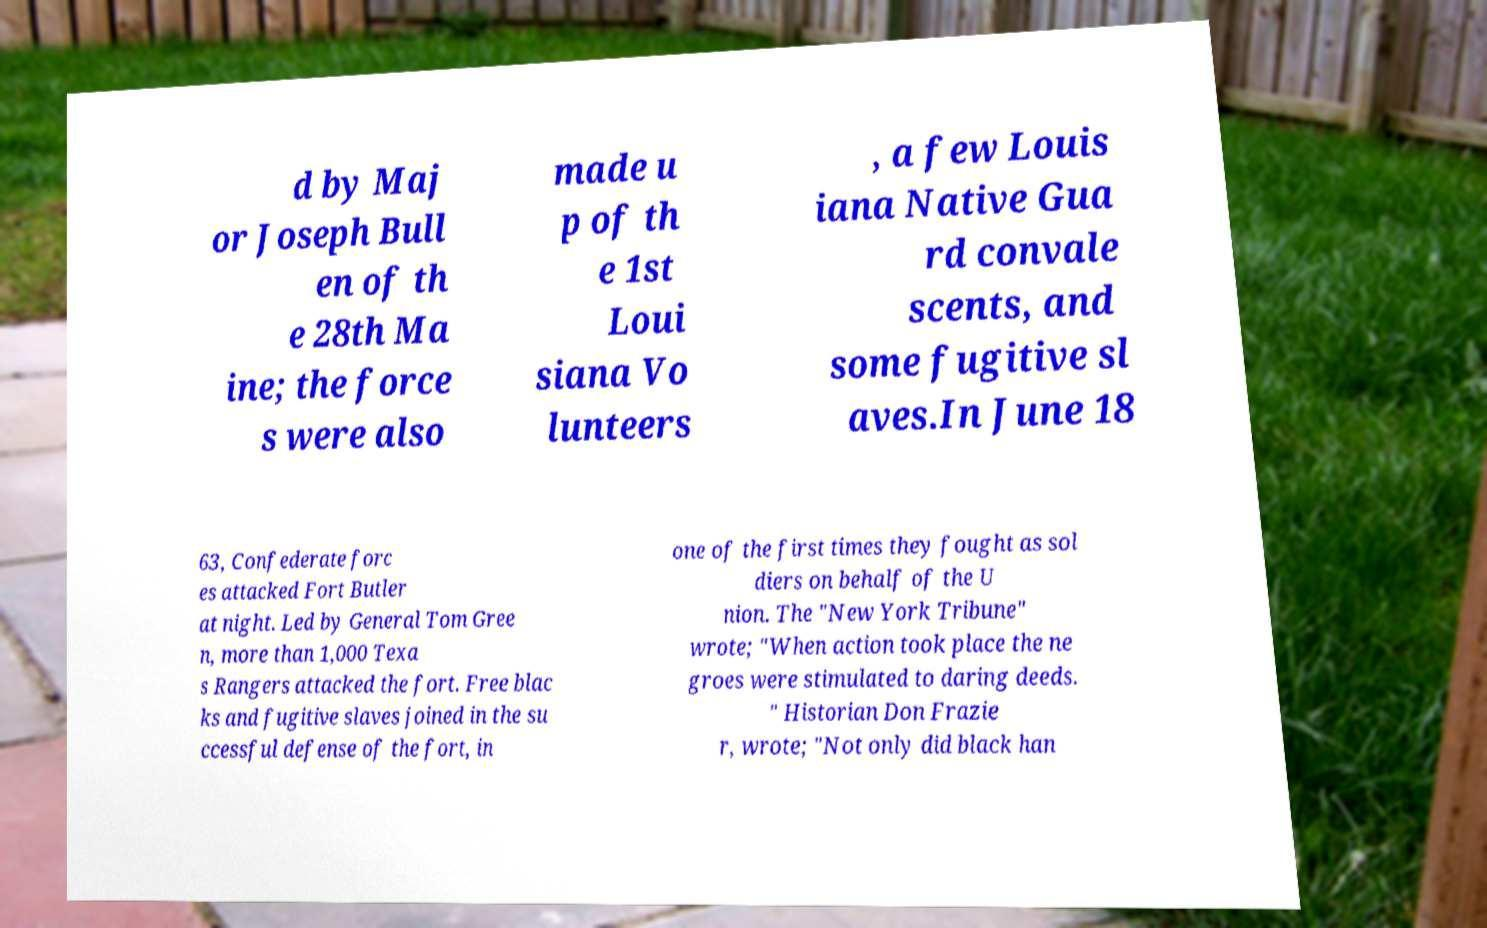Please identify and transcribe the text found in this image. d by Maj or Joseph Bull en of th e 28th Ma ine; the force s were also made u p of th e 1st Loui siana Vo lunteers , a few Louis iana Native Gua rd convale scents, and some fugitive sl aves.In June 18 63, Confederate forc es attacked Fort Butler at night. Led by General Tom Gree n, more than 1,000 Texa s Rangers attacked the fort. Free blac ks and fugitive slaves joined in the su ccessful defense of the fort, in one of the first times they fought as sol diers on behalf of the U nion. The "New York Tribune" wrote; "When action took place the ne groes were stimulated to daring deeds. " Historian Don Frazie r, wrote; "Not only did black han 